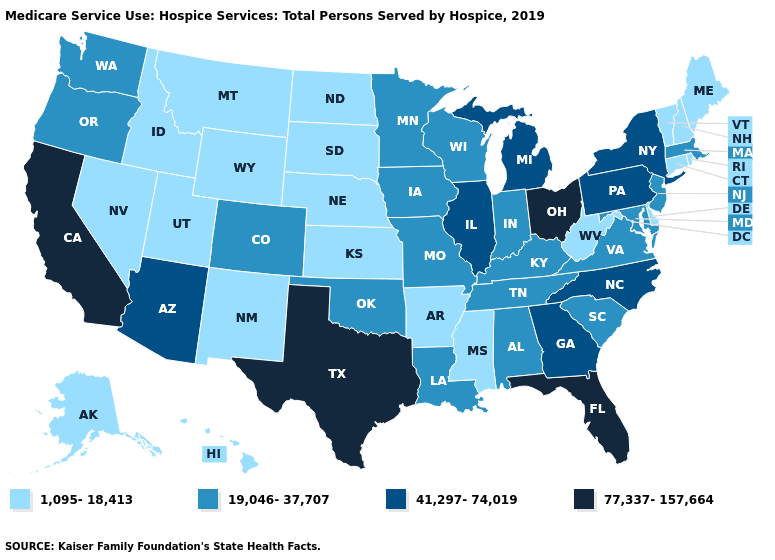What is the value of New Mexico?
Be succinct. 1,095-18,413. Name the states that have a value in the range 77,337-157,664?
Keep it brief. California, Florida, Ohio, Texas. Does Washington have the lowest value in the West?
Give a very brief answer. No. Does South Dakota have the lowest value in the MidWest?
Concise answer only. Yes. Does Pennsylvania have the highest value in the USA?
Give a very brief answer. No. What is the highest value in the West ?
Write a very short answer. 77,337-157,664. Is the legend a continuous bar?
Concise answer only. No. What is the value of Indiana?
Short answer required. 19,046-37,707. Does Pennsylvania have a lower value than Texas?
Write a very short answer. Yes. Name the states that have a value in the range 41,297-74,019?
Write a very short answer. Arizona, Georgia, Illinois, Michigan, New York, North Carolina, Pennsylvania. What is the lowest value in the USA?
Answer briefly. 1,095-18,413. What is the value of Florida?
Write a very short answer. 77,337-157,664. What is the value of Maine?
Short answer required. 1,095-18,413. Which states have the highest value in the USA?
Concise answer only. California, Florida, Ohio, Texas. Does Tennessee have a higher value than Michigan?
Keep it brief. No. 